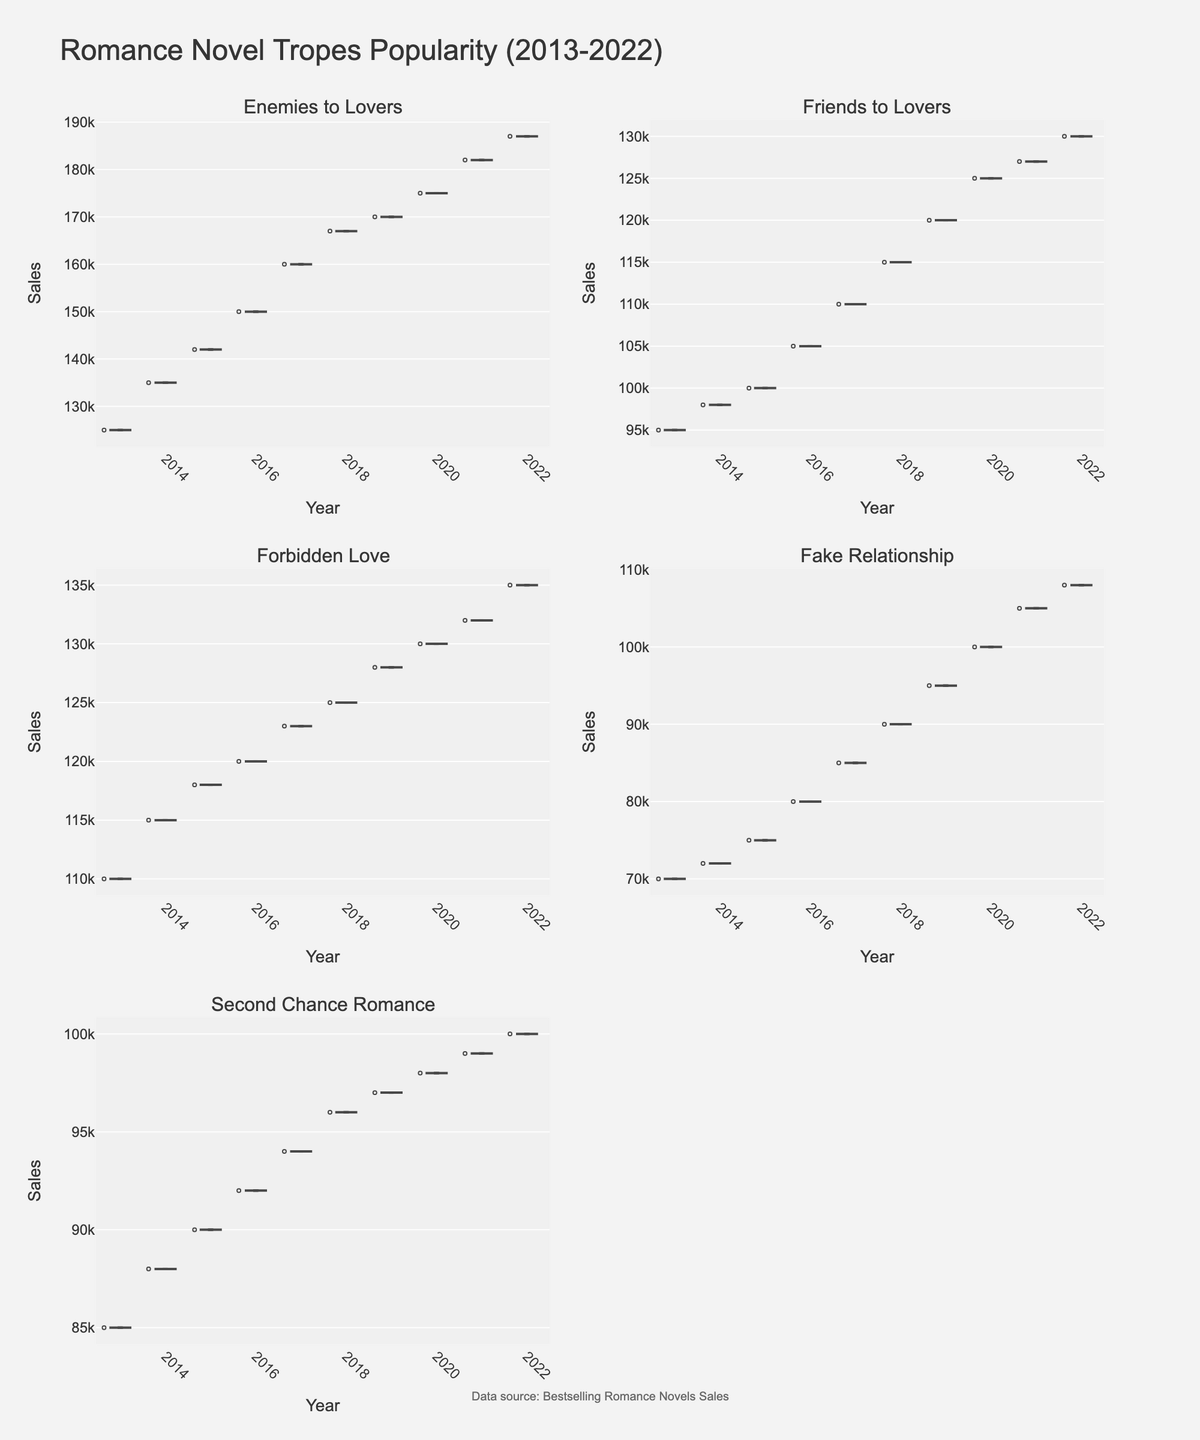Which trope had the highest sales in the year 2022? Look at the sales data for each trope in 2022. The subplot for each trope will show the sales distribution, focusing on the data point for 2022. "Enemies to Lovers" had the highest sales in 2022.
Answer: Enemies to Lovers Which year had the highest average sales across all tropes? To find the year with the highest average sales, examine the mean lines in the violin plots for each year. Calculate average sales for each year by summing up the means for all tropes and dividing by the number of tropes. The year with the highest total mean will have the highest average sales.
Answer: 2022 What is the general trend of the 'Enemies to Lovers' trope from 2013 to 2022? Check the violin plot for 'Enemies to Lovers'. Observe the trend line formed by the mean points for each year from 2013 to 2022. The trend shows the changes in sales over the years.
Answer: Increasing How do the median sales of 'Fake Relationship' compare to 'Second Chance Romance' in 2019? Examine the respective violin plots for 2019. Compare the median lines within the plots of 'Fake Relationship' and 'Second Chance Romance' to determine their relative positions.
Answer: Lower Which trope shows the most variability in sales over the years? Assess the width of the violin plots for each trope. Wider plots indicate higher variability. Identify which subplot has the widest distribution across the years.
Answer: Enemies to Lovers In which year did 'Forbidden Love' have the lowest sales? Examine the 'Forbidden Love' violin plot. Identify the year with the lowest data point within its distribution from 2013 to 2022.
Answer: 2013 How do the sales for 'Friends to Lovers' in 2020 compare to those in 2013? Look at the sales points for 'Friends to Lovers' in 2020 and 2013 within its violin plot. Compare the data points to determine the difference in sales.
Answer: Higher in 2020 What is the average sales range for 'Second Chance Romance' from 2013 to 2022? Observe the 'Second Chance Romance' plot. The range is determined by the difference between the highest and lowest data points. Calculate the average of these two values to get the sales range.
Answer: 92,000 to 100,000 